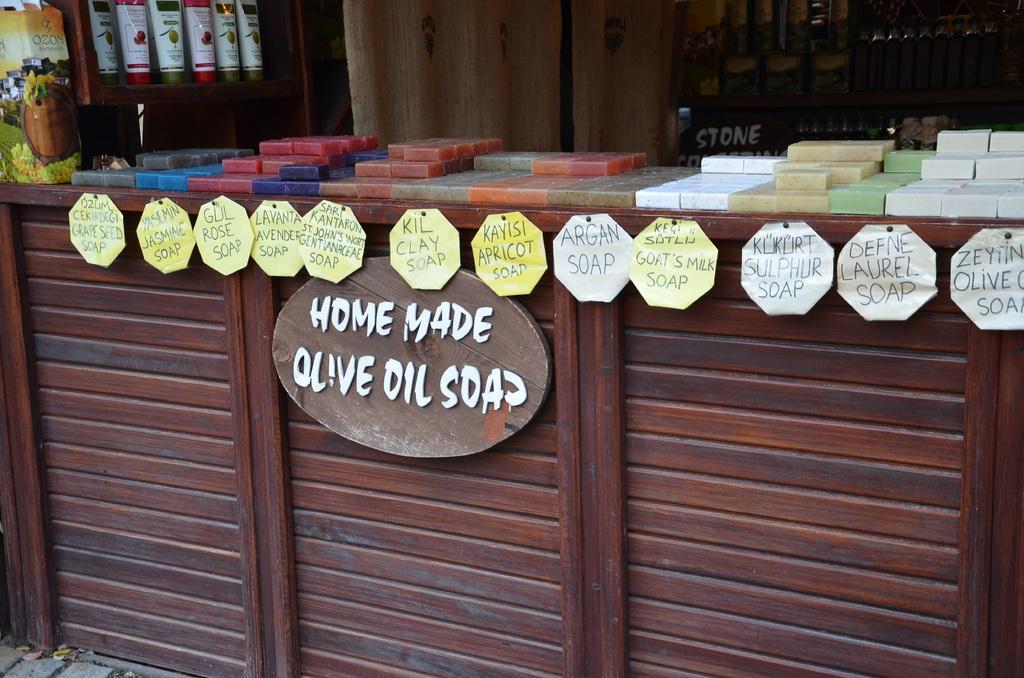Describe this image in one or two sentences. In this image, we can see a wooden desk. On this desk, we can see stickers, board and few objects. Top of the image, we can see racks. Few objects are placed on it. Here we can see curtains and some text. 